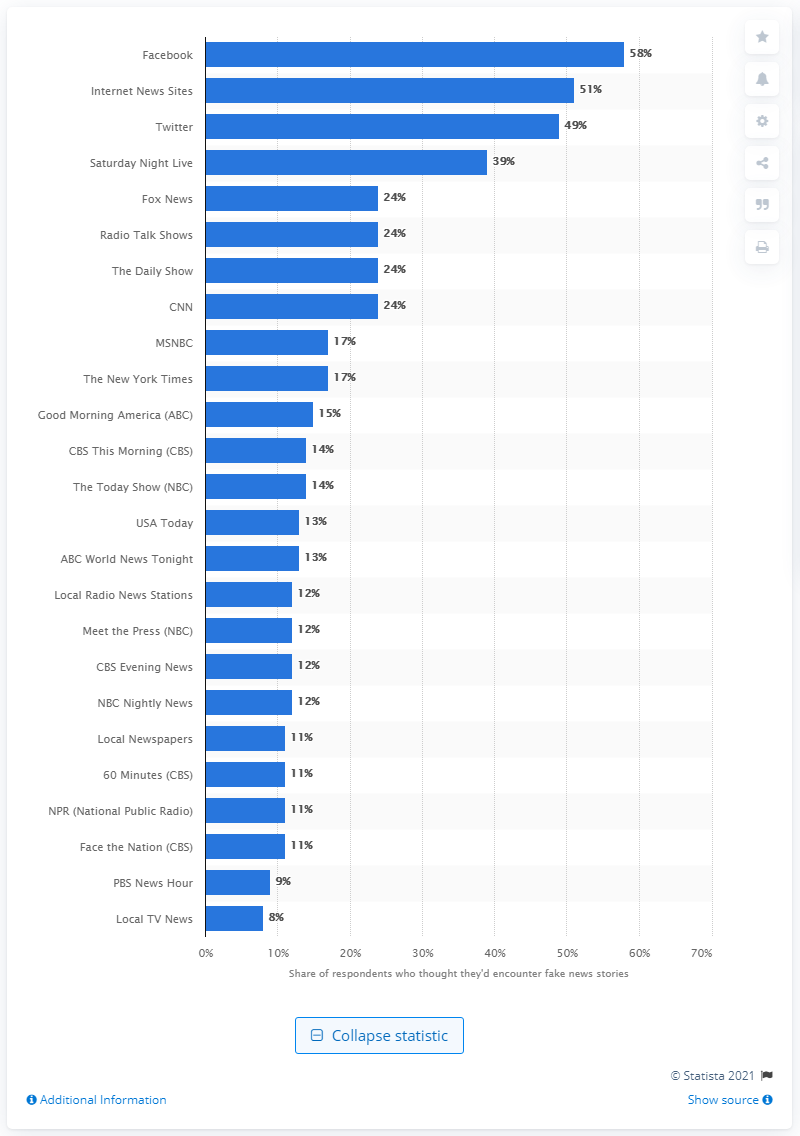Draw attention to some important aspects in this diagram. Facebook is the most likely place where people are likely to encounter false news stories. 